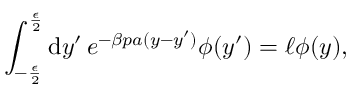Convert formula to latex. <formula><loc_0><loc_0><loc_500><loc_500>\int _ { - \frac { \epsilon } { 2 } } ^ { \frac { \epsilon } { 2 } } d y ^ { \prime } \, e ^ { - \beta p a ( y - y ^ { \prime } ) } \phi ( y ^ { \prime } ) = \ell \phi ( y ) ,</formula> 